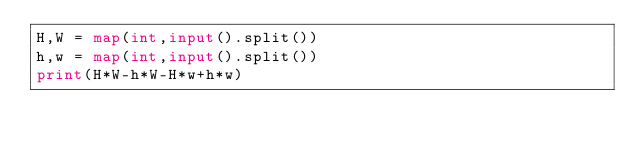<code> <loc_0><loc_0><loc_500><loc_500><_Python_>H,W = map(int,input().split())
h,w = map(int,input().split())
print(H*W-h*W-H*w+h*w)</code> 